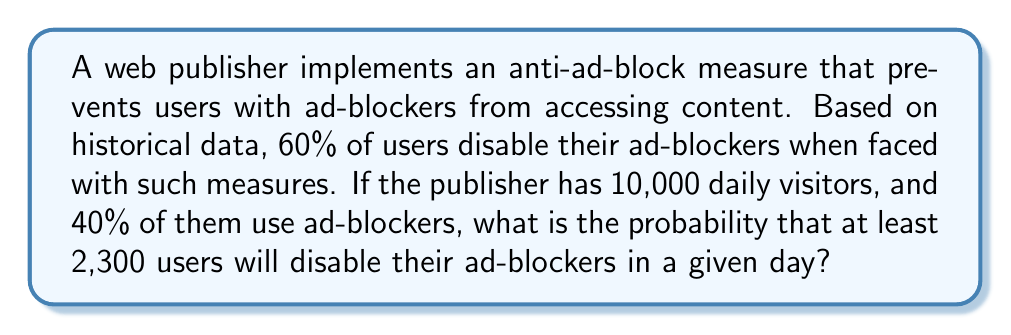Help me with this question. To solve this problem, we'll use the binomial distribution and then apply the normal approximation to the binomial distribution.

1. First, let's identify our variables:
   - $n$ = number of users with ad-blockers = $10,000 \times 0.40 = 4,000$
   - $p$ = probability of disabling ad-blocker = $0.60$
   - $X$ = number of users who disable ad-blockers

2. We want to find $P(X \geq 2300)$

3. For a binomial distribution:
   $\mu = np = 4000 \times 0.60 = 2400$
   $\sigma = \sqrt{np(1-p)} = \sqrt{4000 \times 0.60 \times 0.40} = 31$

4. Since $n$ is large and $np$ and $n(1-p)$ are both greater than 5, we can use the normal approximation to the binomial distribution.

5. We need to apply a continuity correction. Instead of $P(X \geq 2300)$, we calculate $P(X > 2299.5)$

6. Standardizing the normal distribution:
   $z = \frac{2299.5 - 2400}{31} = -3.24$

7. Using the standard normal distribution table or calculator, we find:
   $P(Z > -3.24) = 1 - P(Z < -3.24) = 1 - 0.0006 = 0.9994$

Therefore, the probability that at least 2,300 users will disable their ad-blockers is approximately 0.9994 or 99.94%.
Answer: $P(X \geq 2300) \approx 0.9994$ or $99.94\%$ 